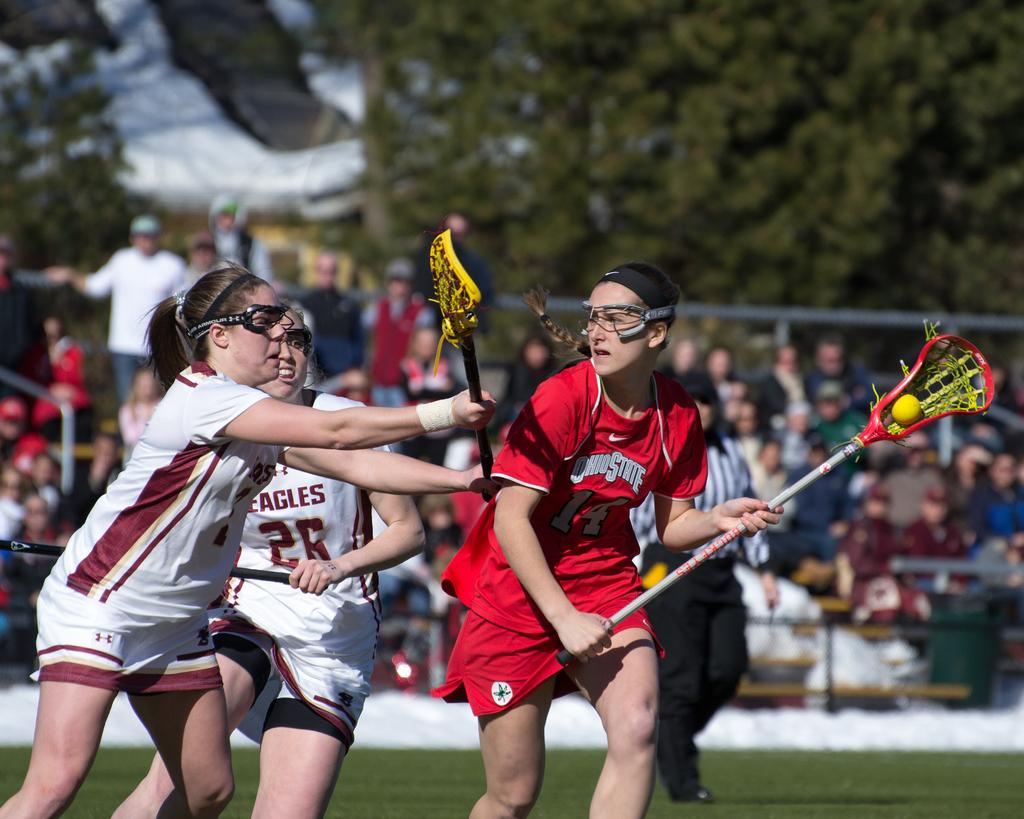<image>
Describe the image concisely. the team in white jersey is the Eagles 